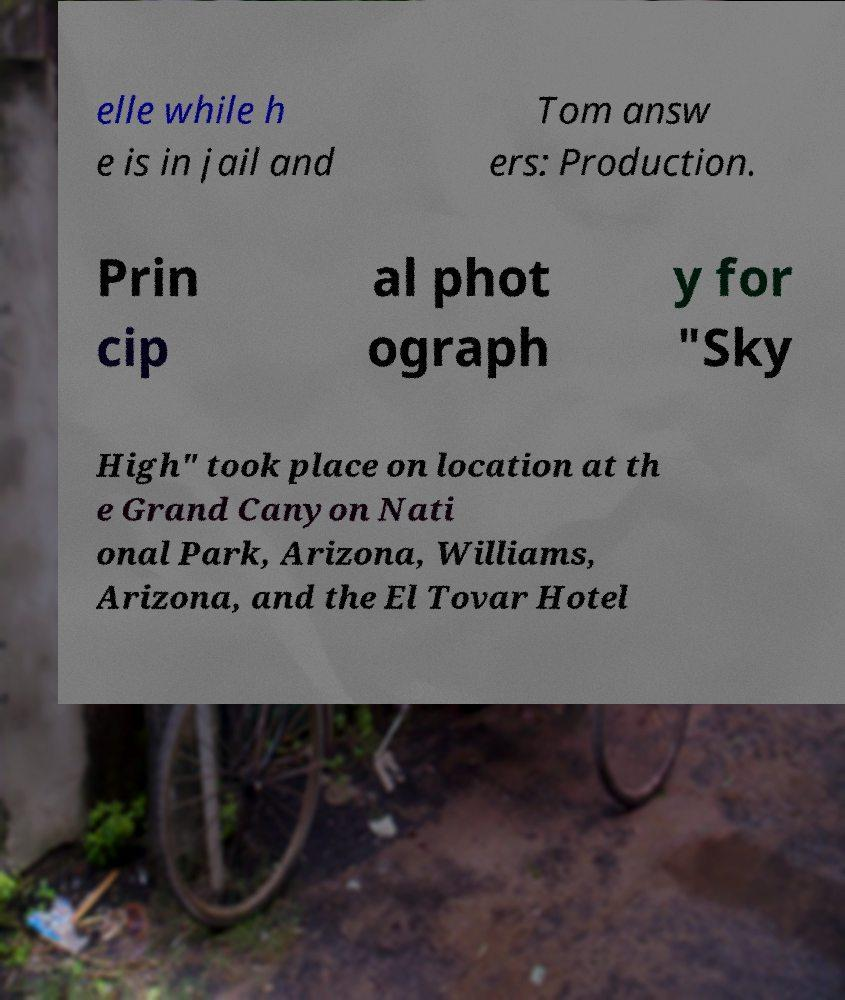Please read and relay the text visible in this image. What does it say? elle while h e is in jail and Tom answ ers: Production. Prin cip al phot ograph y for "Sky High" took place on location at th e Grand Canyon Nati onal Park, Arizona, Williams, Arizona, and the El Tovar Hotel 